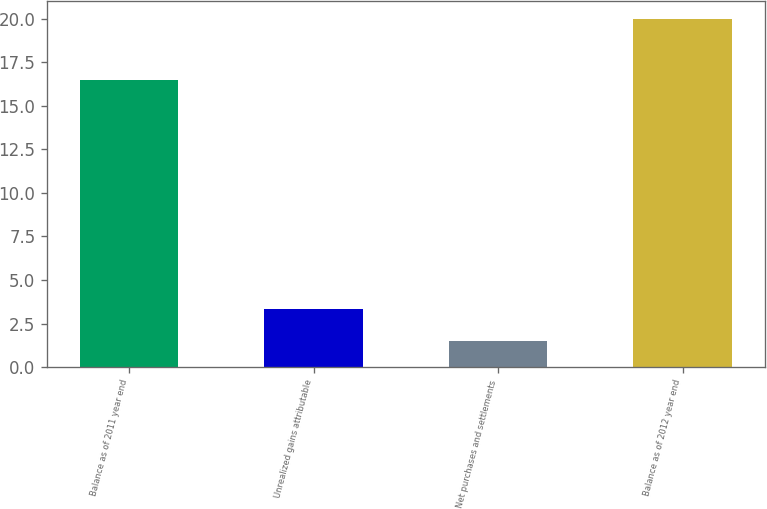Convert chart to OTSL. <chart><loc_0><loc_0><loc_500><loc_500><bar_chart><fcel>Balance as of 2011 year end<fcel>Unrealized gains attributable<fcel>Net purchases and settlements<fcel>Balance as of 2012 year end<nl><fcel>16.5<fcel>3.35<fcel>1.5<fcel>20<nl></chart> 